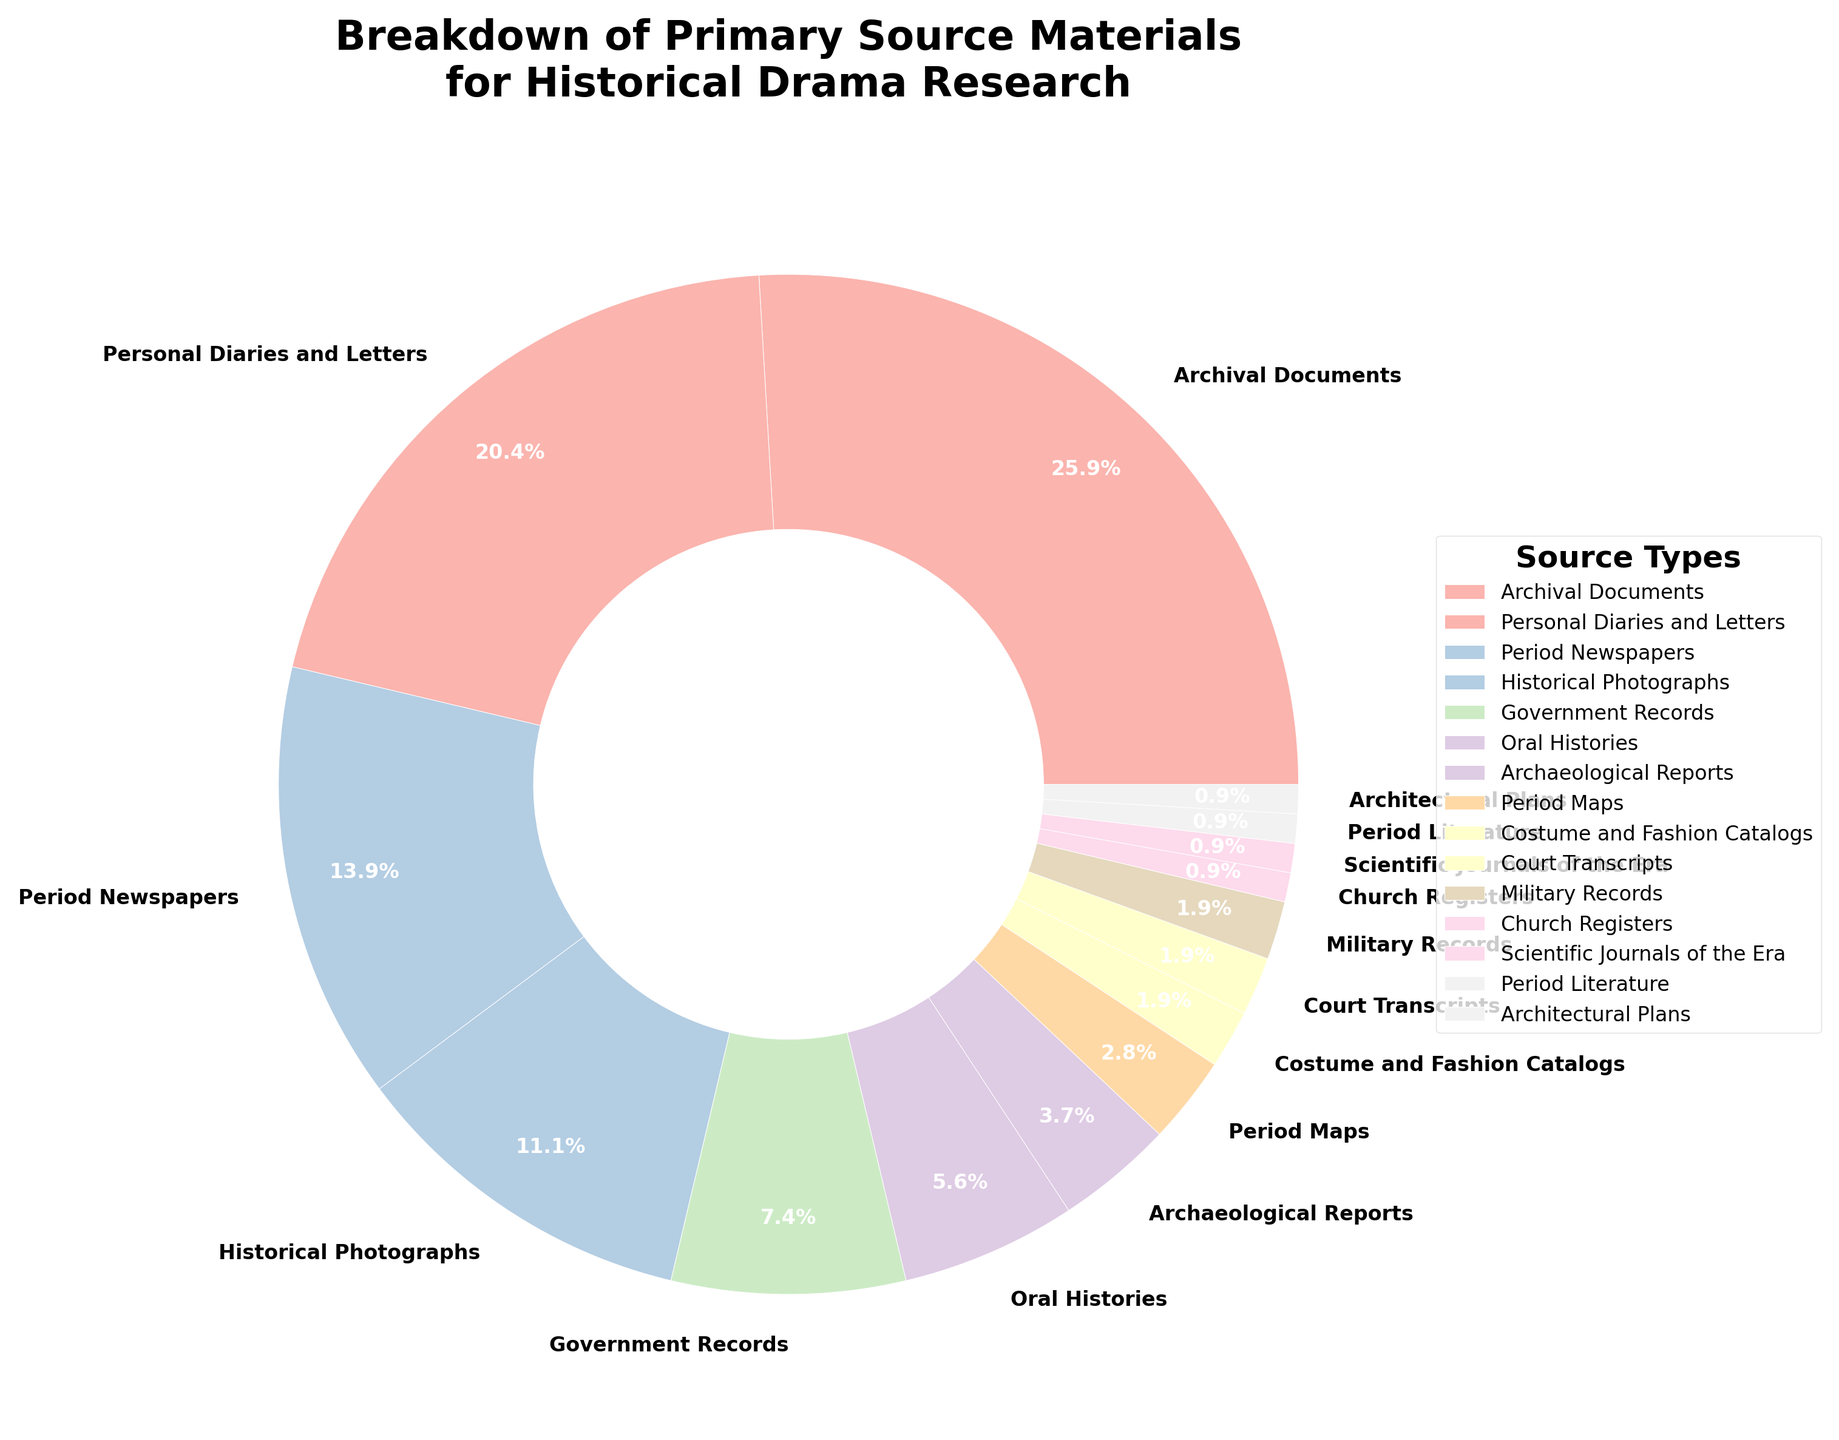what is the total percentage of the least common sources combined? First, identify the least common sources from the pie chart, which are sources with a percentage of 1% each (Church Registers, Scientific Journals of the Era, Period Literature, and Architectural Plans). Sum these percentages: 1% + 1% + 1% + 1% = 4%.
Answer: 4% Which source type has a higher percentage: Government Records or Personal Diaries and Letters? Compare the percentages for Government Records (8%) and Personal Diaries and Letters (22%). Personal Diaries and Letters have a higher percentage.
Answer: Personal Diaries and Letters What is the difference in percentage between the most common and the least common source types? Identify the most common source type (Archival Documents at 28%) and the least common source type (several sources at 1%). Subtract the smallest percentage from the largest: 28% - 1% = 27%.
Answer: 27% How many source types have a percentage greater than 10%? Identify the source types with percentages greater than 10% from the pie chart: Archival Documents (28%), Personal Diaries and Letters (22%), Period Newspapers (15%), Historical Photographs (12%). Count these sources: 4.
Answer: 4 Are there more types of sources with a percentage lower than 5% or greater than 10%? Count the source types with percentages lower than 5%: Archaeological Reports (4%), Period Maps (3%), Costume and Fashion Catalogs (2%), Court Transcripts (2%), Military Records (2%), Church Registers (1%), Scientific Journals of the Era (1%), Period Literature (1%), Architectural Plans (1%) – a total of 9. Count the sources with percentages greater than 10%: Archival Documents (28%), Personal Diaries and Letters (22%), Period Newspapers (15%), Historical Photographs (12%) – a total of 4. Comparing the counts, more sources are lower than 5%.
Answer: lower than 5% Which source type is represented by the lightest color in the pie chart? Typically, lighter colors are assigned towards the end of color gradients. Identify the source type with the smallest percentage (1%), which are: Church Registers, Scientific Journals of the Era, Period Literature, and Architectural Plans. All these sources are represented by the lightest colors due to their smallest percentages.
Answer: Church Registers, Scientific Journals of the Era, Period Literature, Architectural Plans What is the relative percentage contribution of Period Newspapers to the top three most common source types? Identify the top three most common source types: Archival Documents (28%), Personal Diaries and Letters (22%), Period Newspapers (15%). Calculate their total percentage: 28% + 22% + 15% = 65%. The relative contribution of Period Newspapers: (15/65) * 100 ≈ 23.1%.
Answer: 23.1% What is the sum percentage of sources related to visual or tangible artifacts (Photographs, Maps, Costume and Fashion Catalogs)? Add the percentages for visual or tangible artifacts categories: Historical Photographs (12%), Period Maps (3%), Costume and Fashion Catalogs (2%). Sum these percentages: 12% + 3% + 2% = 17%.
Answer: 17% 